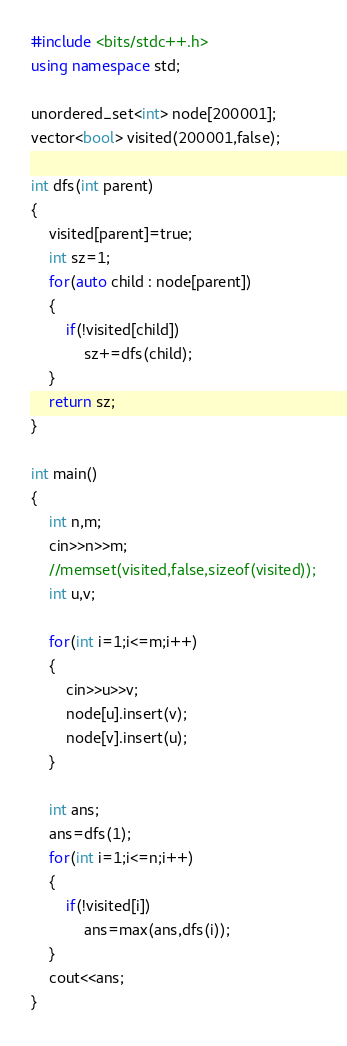Convert code to text. <code><loc_0><loc_0><loc_500><loc_500><_C++_>#include <bits/stdc++.h>
using namespace std;

unordered_set<int> node[200001];
vector<bool> visited(200001,false);

int dfs(int parent)
{
    visited[parent]=true;
    int sz=1;
    for(auto child : node[parent])
    {
        if(!visited[child])
            sz+=dfs(child);
    }
    return sz;
}

int main() 
{
    int n,m;
    cin>>n>>m;
    //memset(visited,false,sizeof(visited));
    int u,v;

    for(int i=1;i<=m;i++)
    {
        cin>>u>>v;
        node[u].insert(v);
        node[v].insert(u);
    }

    int ans;
    ans=dfs(1);
    for(int i=1;i<=n;i++)
    {
        if(!visited[i])
            ans=max(ans,dfs(i));
    }
    cout<<ans;
}
</code> 